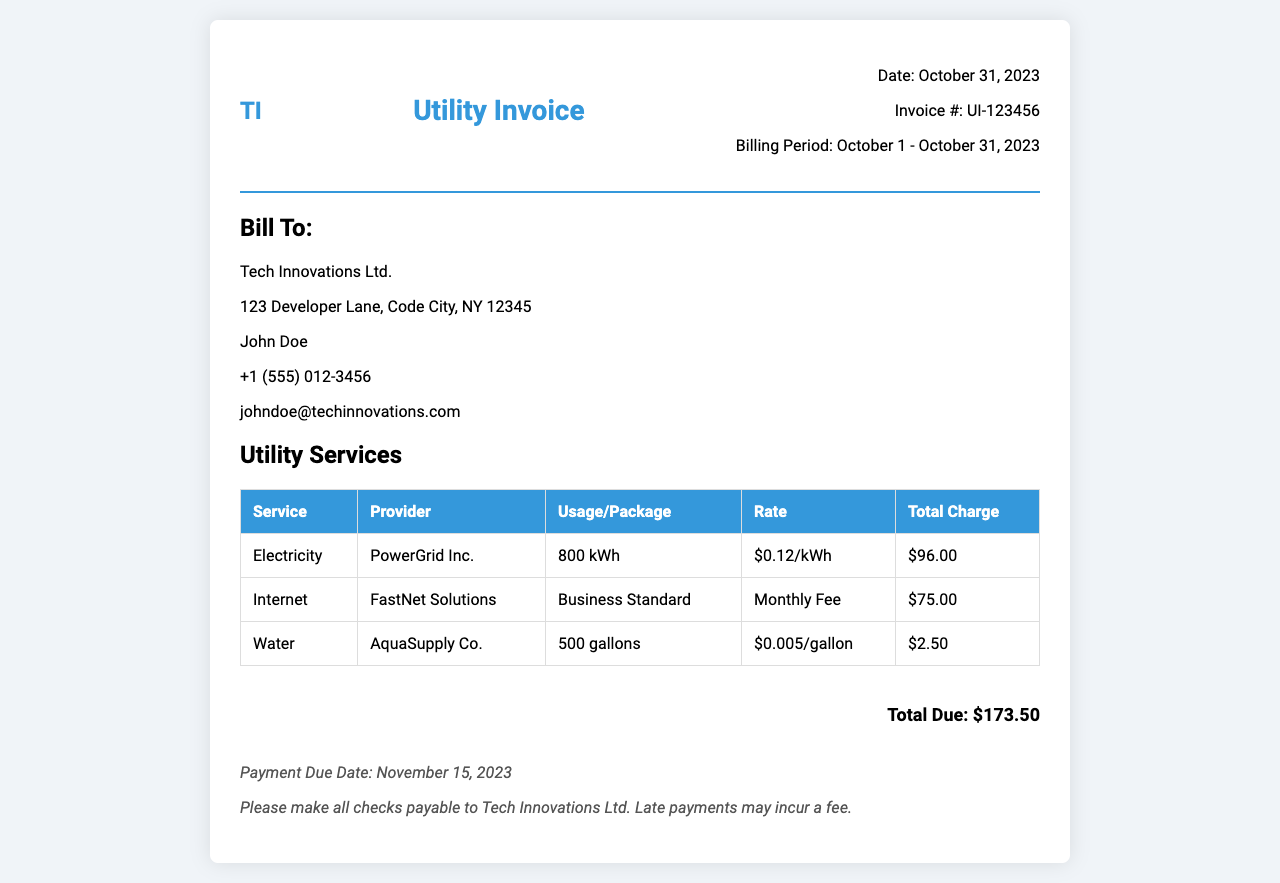What is the invoice number? The invoice number is mentioned in the document as UI-123456.
Answer: UI-123456 What is the billing period? The billing period covers the dates from October 1 to October 31, 2023.
Answer: October 1 - October 31, 2023 Who is the electricity provider? The electricity provider is listed as PowerGrid Inc. in the utility services section.
Answer: PowerGrid Inc What is the total charge for water? The total charge for water is calculated and presented in the table as $2.50.
Answer: $2.50 What is the payment due date? The payment due date is specifically noted in the document as November 15, 2023.
Answer: November 15, 2023 How many kilowatt-hours of electricity were used? The document specifies that 800 kilowatt-hours of electricity were used during the billing period.
Answer: 800 kWh What is the monthly fee for internet service? The document states that the monthly fee for internet service is $75.00.
Answer: $75.00 What is the total amount due? The total amount due at the end of the invoice is clearly stated as $173.50.
Answer: $173.50 